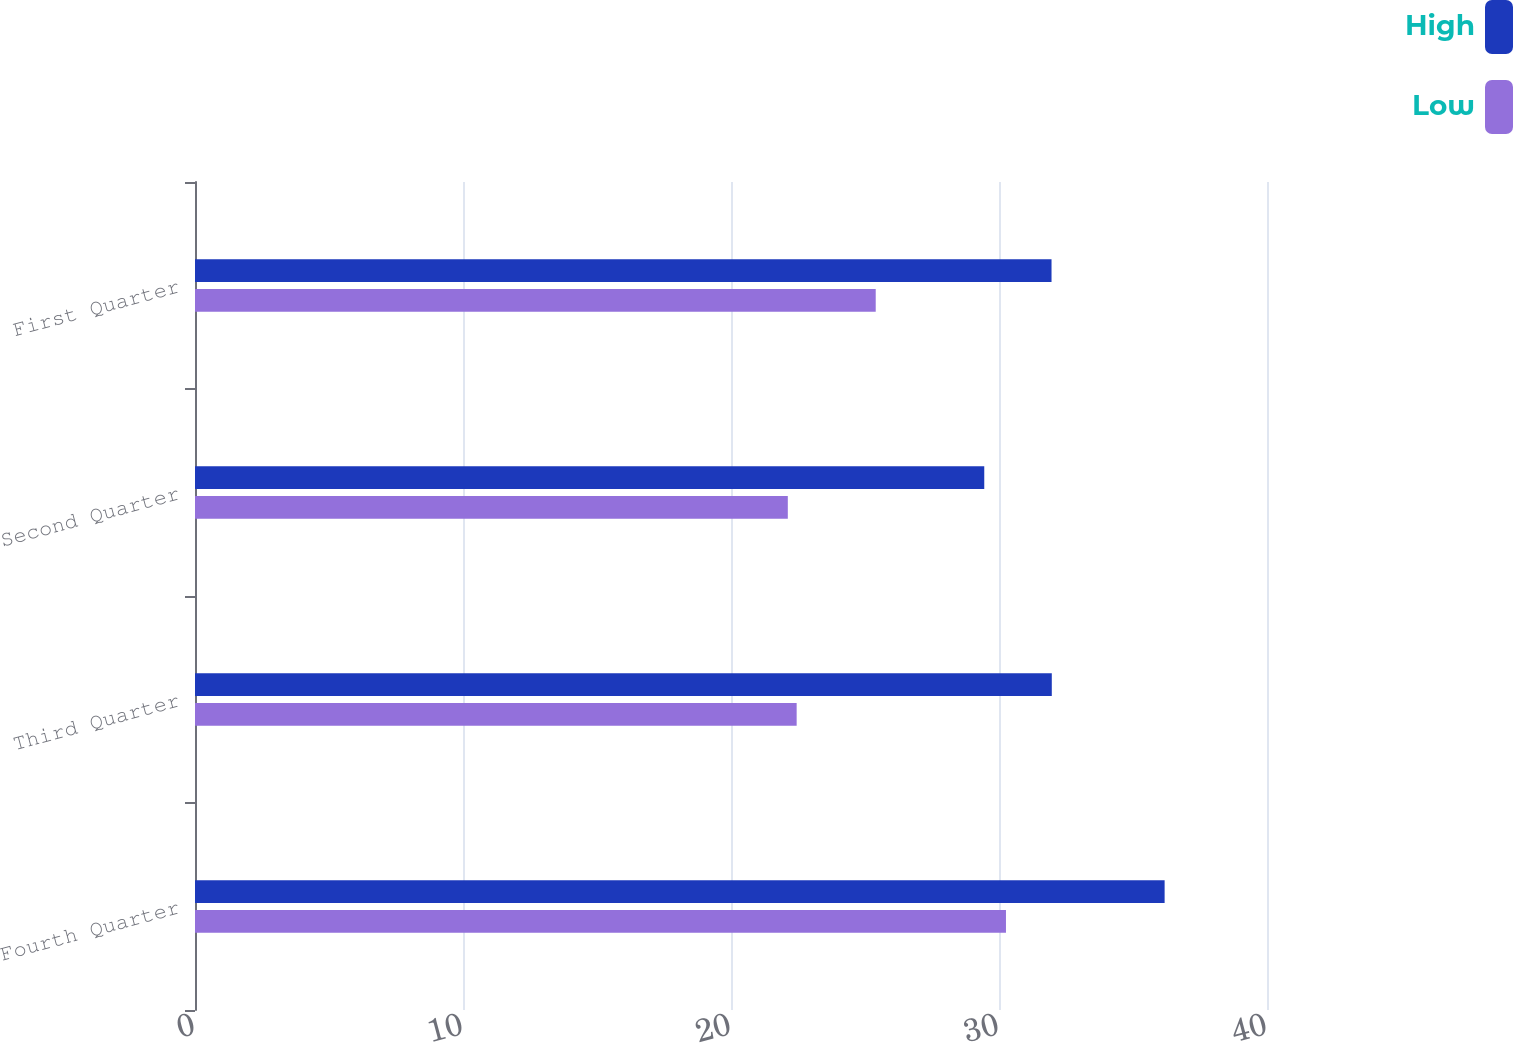<chart> <loc_0><loc_0><loc_500><loc_500><stacked_bar_chart><ecel><fcel>Fourth Quarter<fcel>Third Quarter<fcel>Second Quarter<fcel>First Quarter<nl><fcel>High<fcel>36.18<fcel>31.97<fcel>29.45<fcel>31.96<nl><fcel>Low<fcel>30.26<fcel>22.45<fcel>22.12<fcel>25.4<nl></chart> 